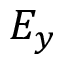<formula> <loc_0><loc_0><loc_500><loc_500>E _ { y }</formula> 